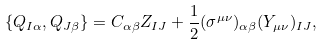<formula> <loc_0><loc_0><loc_500><loc_500>\{ Q _ { I \alpha } , Q _ { J \beta } \} = C _ { \alpha \beta } Z _ { I J } + \frac { 1 } { 2 } ( \sigma ^ { \mu \nu } ) _ { \alpha \beta } ( Y _ { \mu \nu } ) _ { I J } ,</formula> 